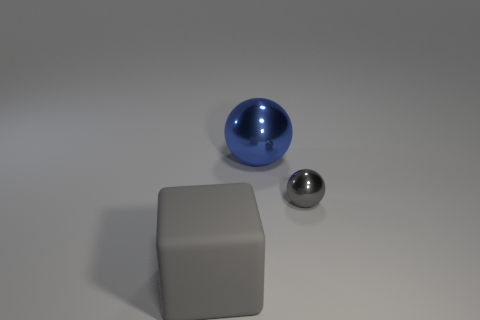What is the material of the other blue object that is the same shape as the small metal thing?
Your answer should be very brief. Metal. Is there another small gray metal object of the same shape as the tiny gray shiny object?
Offer a very short reply. No. How many other big gray rubber things are the same shape as the matte object?
Give a very brief answer. 0. Does the shiny sphere that is to the left of the gray shiny sphere have the same size as the gray thing that is behind the matte object?
Ensure brevity in your answer.  No. There is a metallic thing that is to the right of the sphere that is behind the small gray sphere; what is its shape?
Give a very brief answer. Sphere. Is the number of gray rubber things on the right side of the small thing the same as the number of big cyan cylinders?
Your response must be concise. Yes. What material is the gray object behind the large thing left of the shiny thing that is behind the gray shiny ball?
Offer a very short reply. Metal. Is there a shiny object of the same size as the rubber block?
Make the answer very short. Yes. The big blue thing is what shape?
Make the answer very short. Sphere. How many balls are green objects or big blue shiny objects?
Provide a short and direct response. 1. 